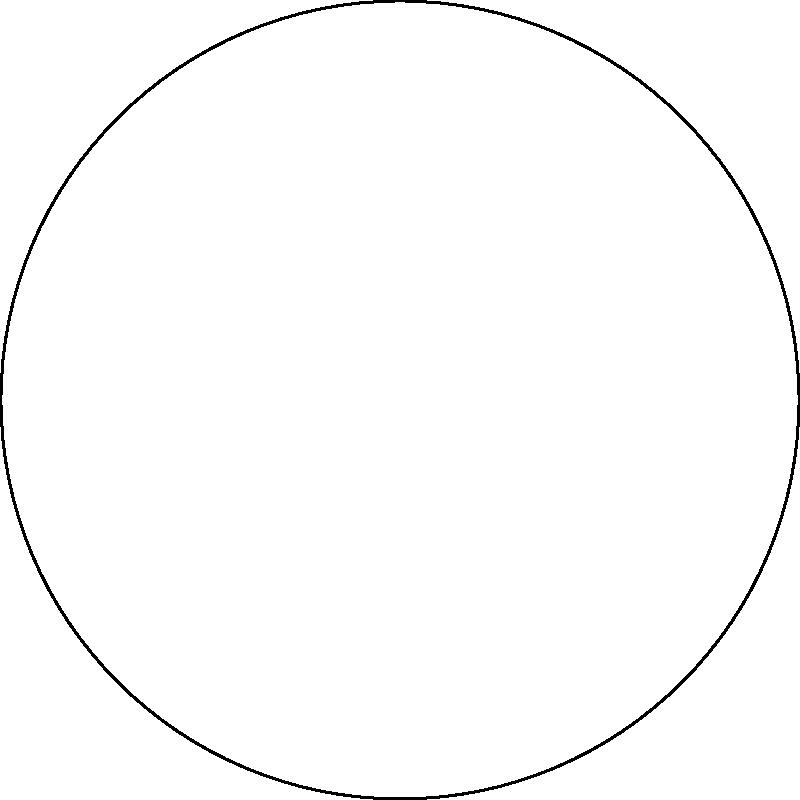In the circular diagram representing the stages of addiction recovery, which stage is directly opposite to the "Action" stage? To determine the stage directly opposite to "Action" in the circular diagram, we need to follow these steps:

1. Identify the position of the "Action" stage:
   The "Action" stage is located at the bottom of the circle (180 degrees).

2. Understand the concept of opposite positions in a circle:
   Opposite positions are 180 degrees apart in a circular diagram.

3. Calculate the opposite position:
   The opposite of 180 degrees is 0 degrees (or 360 degrees).

4. Identify the stage at 0 degrees:
   The stage located at the top of the circle (0 degrees) is "Pre-contemplation".

Therefore, the stage directly opposite to the "Action" stage in this circular diagram of addiction recovery is "Pre-contemplation".

This arrangement reflects the cyclical nature of addiction recovery, where individuals may move through different stages, sometimes progressing forward and sometimes moving backward in their journey.
Answer: Pre-contemplation 